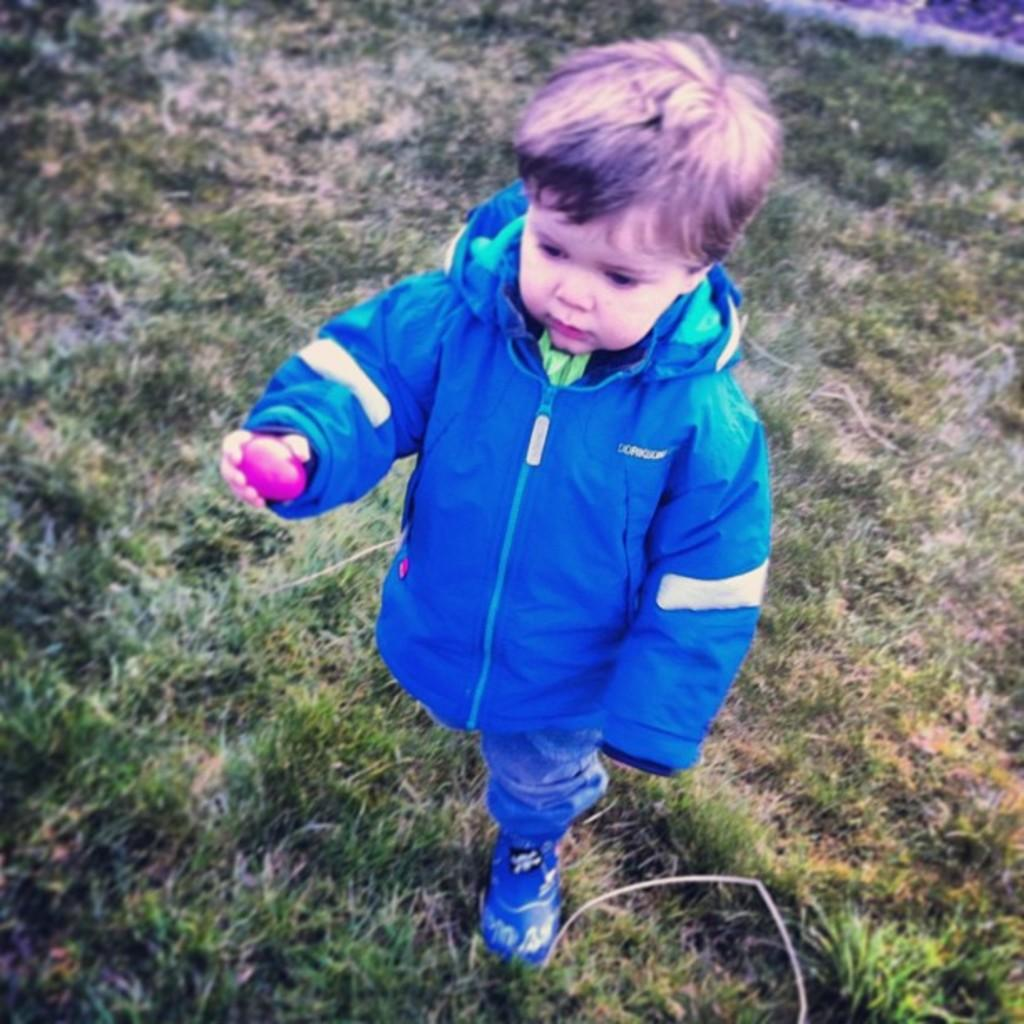What is the main subject of the image? The main subject of the image is a boy. What is the boy doing in the image? The boy is walking in the image. What is the boy holding in the image? The boy is holding something in the image. What type of terrain is visible at the bottom of the image? There is grass at the bottom of the image. What grade does the boy receive for his performance in the image? There is no indication of a performance or grading system in the image, as it simply shows a boy walking while holding something. 